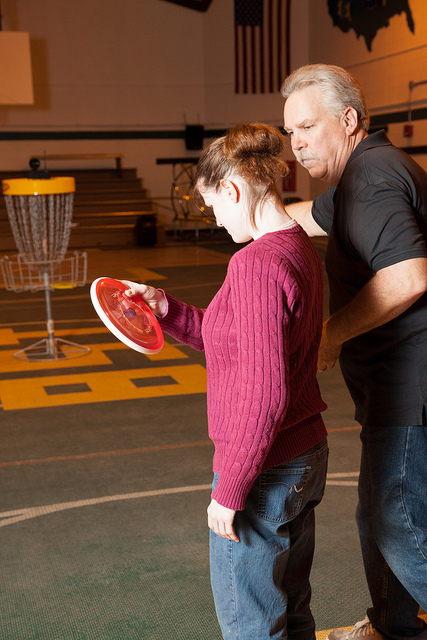<image>What game is this little boy playing? It's ambiguous what game the little boy is playing since there's no boy visible in the image. However, Frisbee or Frisbee golf could be possible options. What game is this little boy playing? I am not sure what game the little boy is playing. It can be frisbee, disc golf, or frisbee golf. 